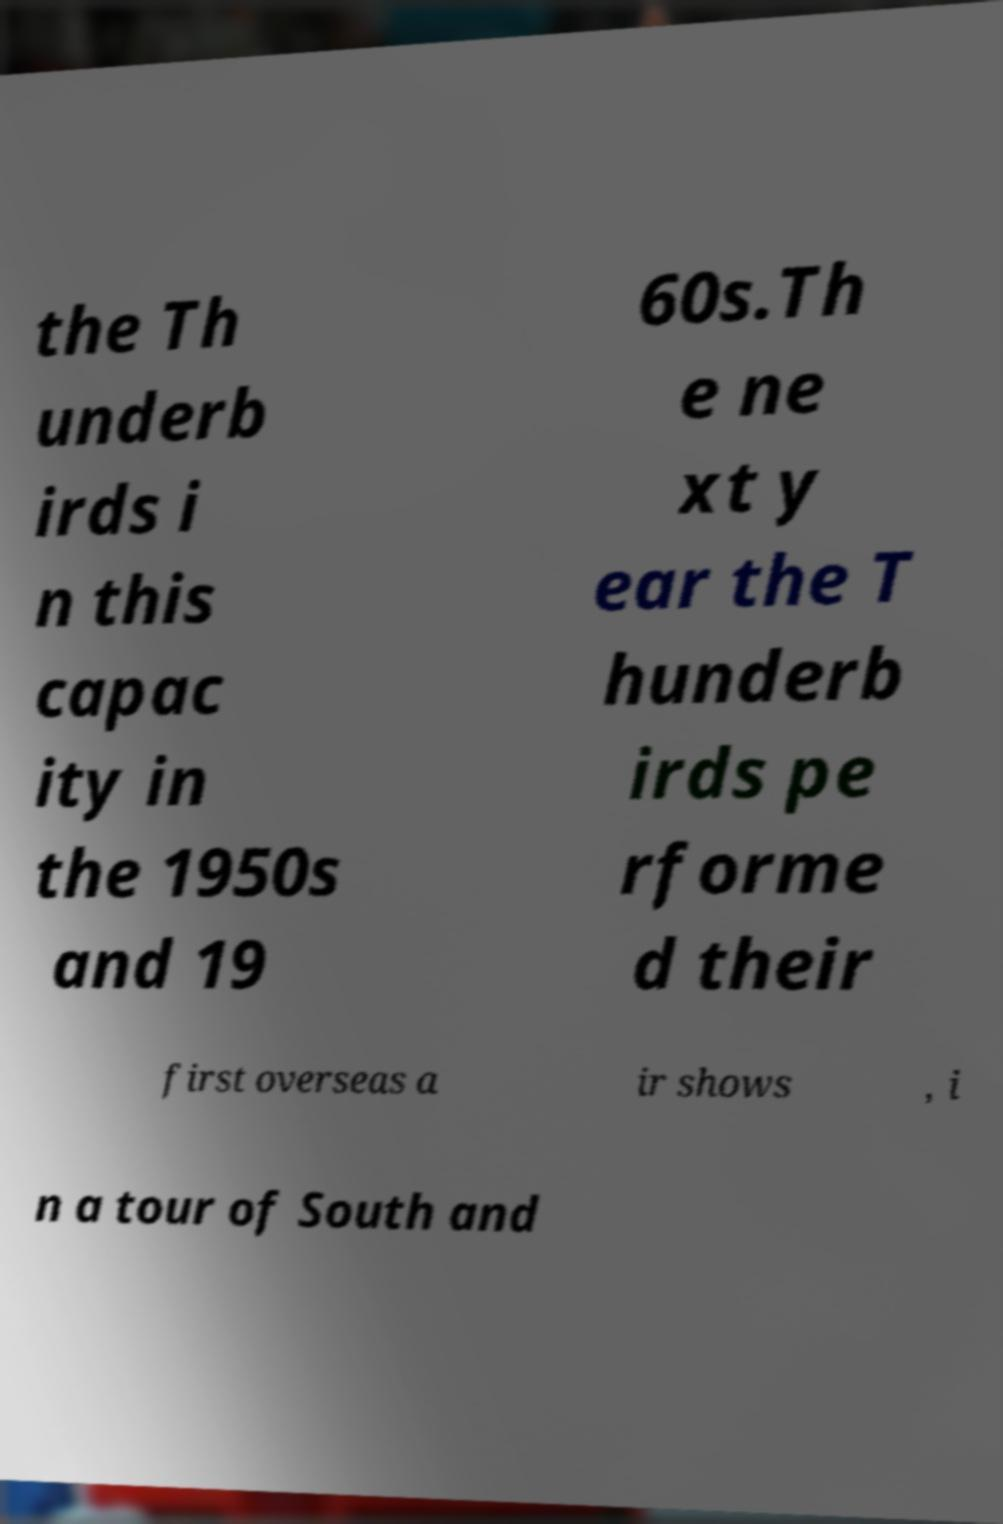Please read and relay the text visible in this image. What does it say? the Th underb irds i n this capac ity in the 1950s and 19 60s.Th e ne xt y ear the T hunderb irds pe rforme d their first overseas a ir shows , i n a tour of South and 